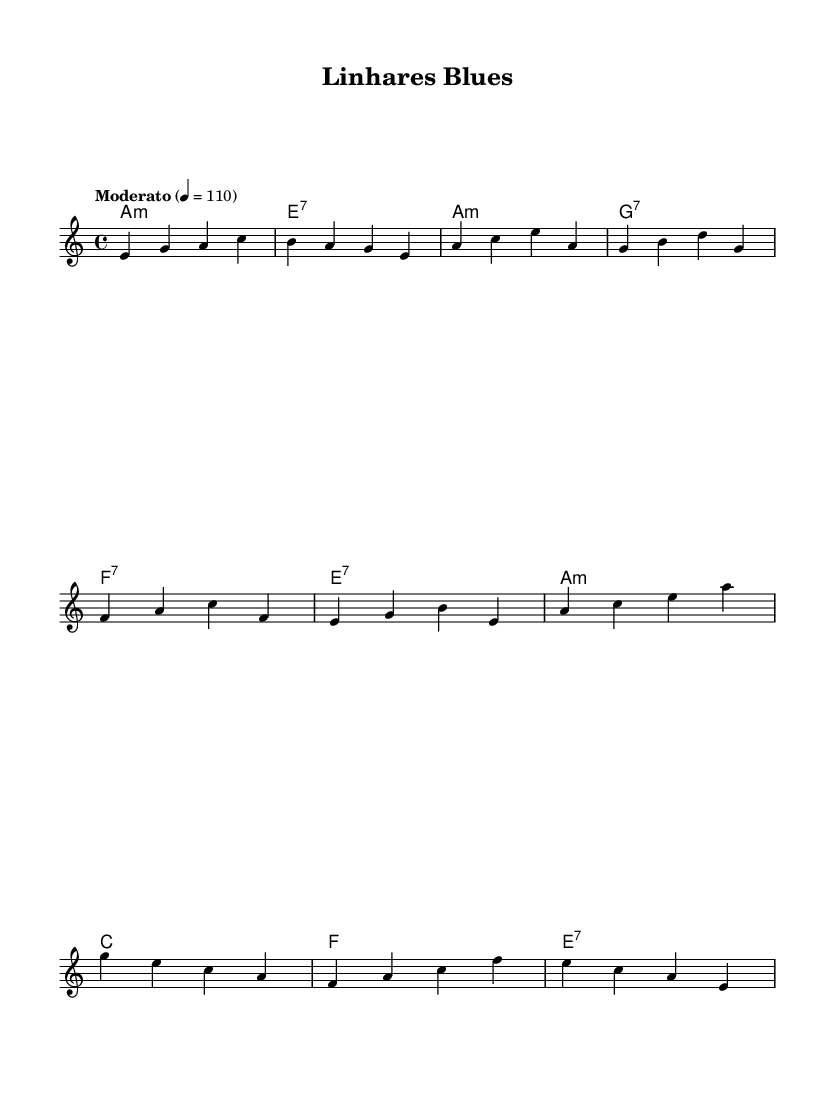What is the key signature of this music? The key signature is indicated by the key of A minor, which has no sharps or flats. This can be inferred from the global section of the code where the key is specifically noted.
Answer: A minor What is the time signature of the piece? The time signature is 4/4, which means there are four beats in each measure and the quarter note receives one beat. This is explicitly shown in the global section of the code.
Answer: 4/4 What is the tempo marking of this piece? The tempo is marked as "Moderato" with a metronome marking of 110 beats per minute. This is detailed in the tempo indication in the global section.
Answer: Moderato 4 = 110 How many measures are in the chorus? The chorus consists of four measures, as demonstrated in the melody and the corresponding lyrics section, which visually indicates the divisions into measures.
Answer: 4 Which chord is played in the first measure? The first measure features an A minor chord. This can be deduced from the harmonies section, where the first chord is clearly labeled as A1:m.
Answer: A minor What type of blues is this piece integrating? The piece uniquely combines traditional blues with Brazilian rhythms, seen in the overall theme and lyrical content that suggests a cultural fusion. This understanding derives from the description connected to the music's title and context.
Answer: Brazilian rhythms What is the main theme of the lyrics in the first verse? The main theme revolves around standing in Linhares and a snarky acknowledgment that many may not know where it is. This is recognized through the specific wording in the lyrics segment of the verse.
Answer: Linhares town 